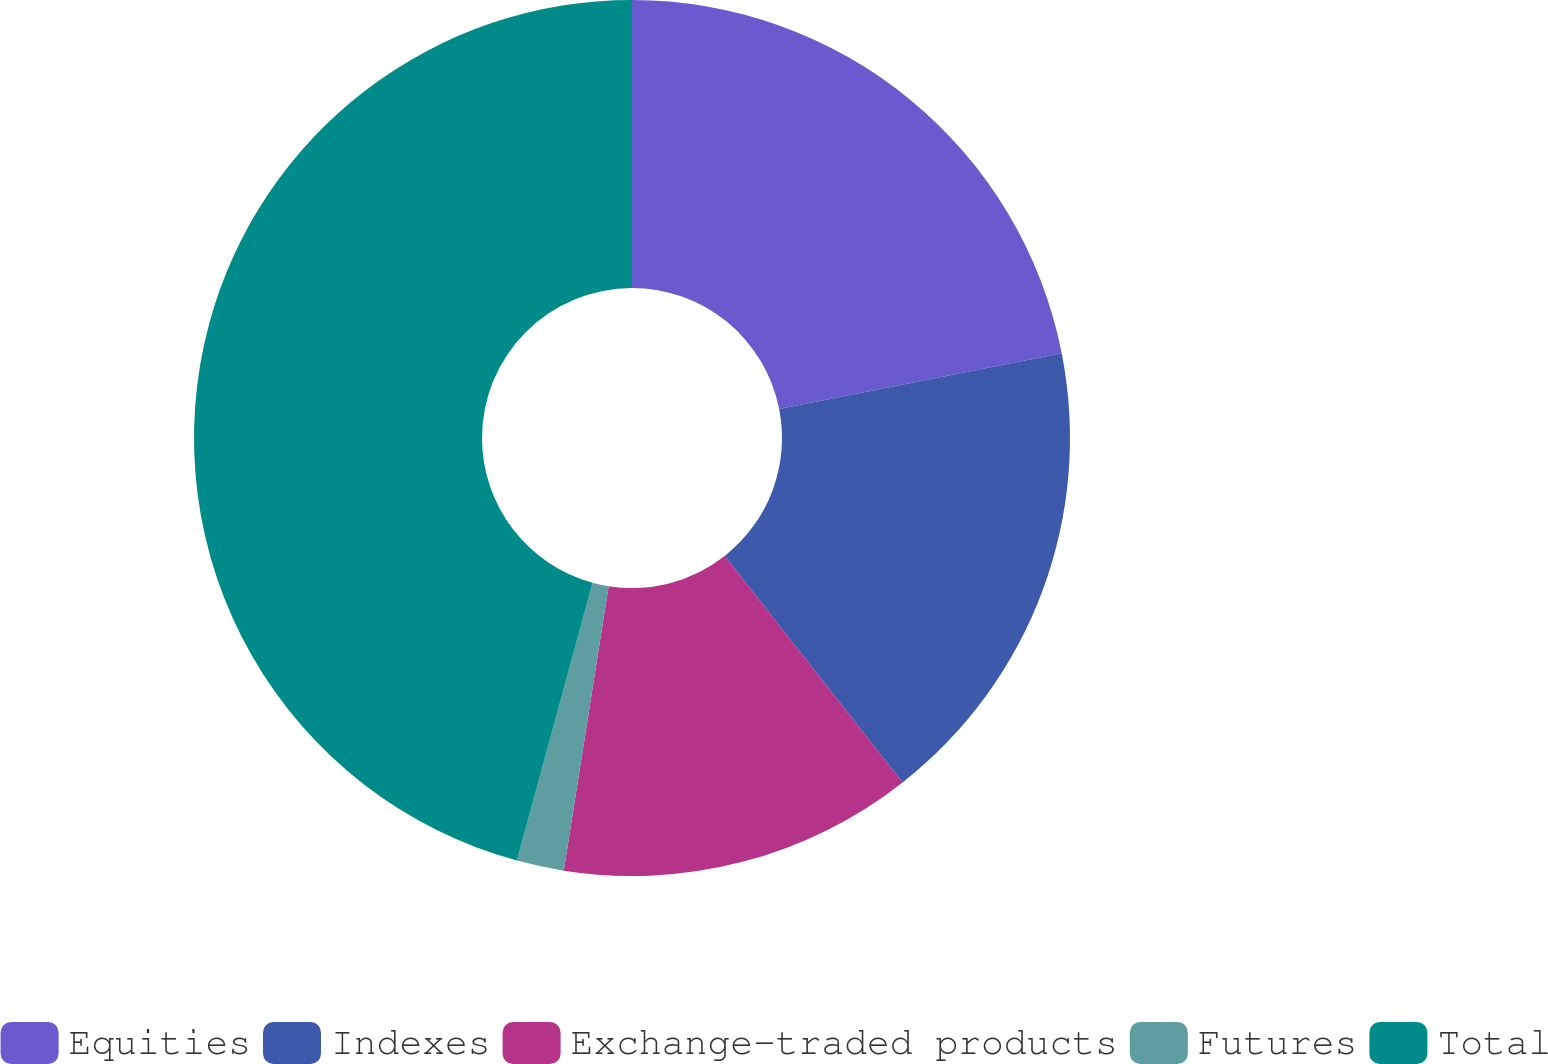Convert chart. <chart><loc_0><loc_0><loc_500><loc_500><pie_chart><fcel>Equities<fcel>Indexes<fcel>Exchange-traded products<fcel>Futures<fcel>Total<nl><fcel>21.9%<fcel>17.5%<fcel>13.09%<fcel>1.74%<fcel>45.77%<nl></chart> 